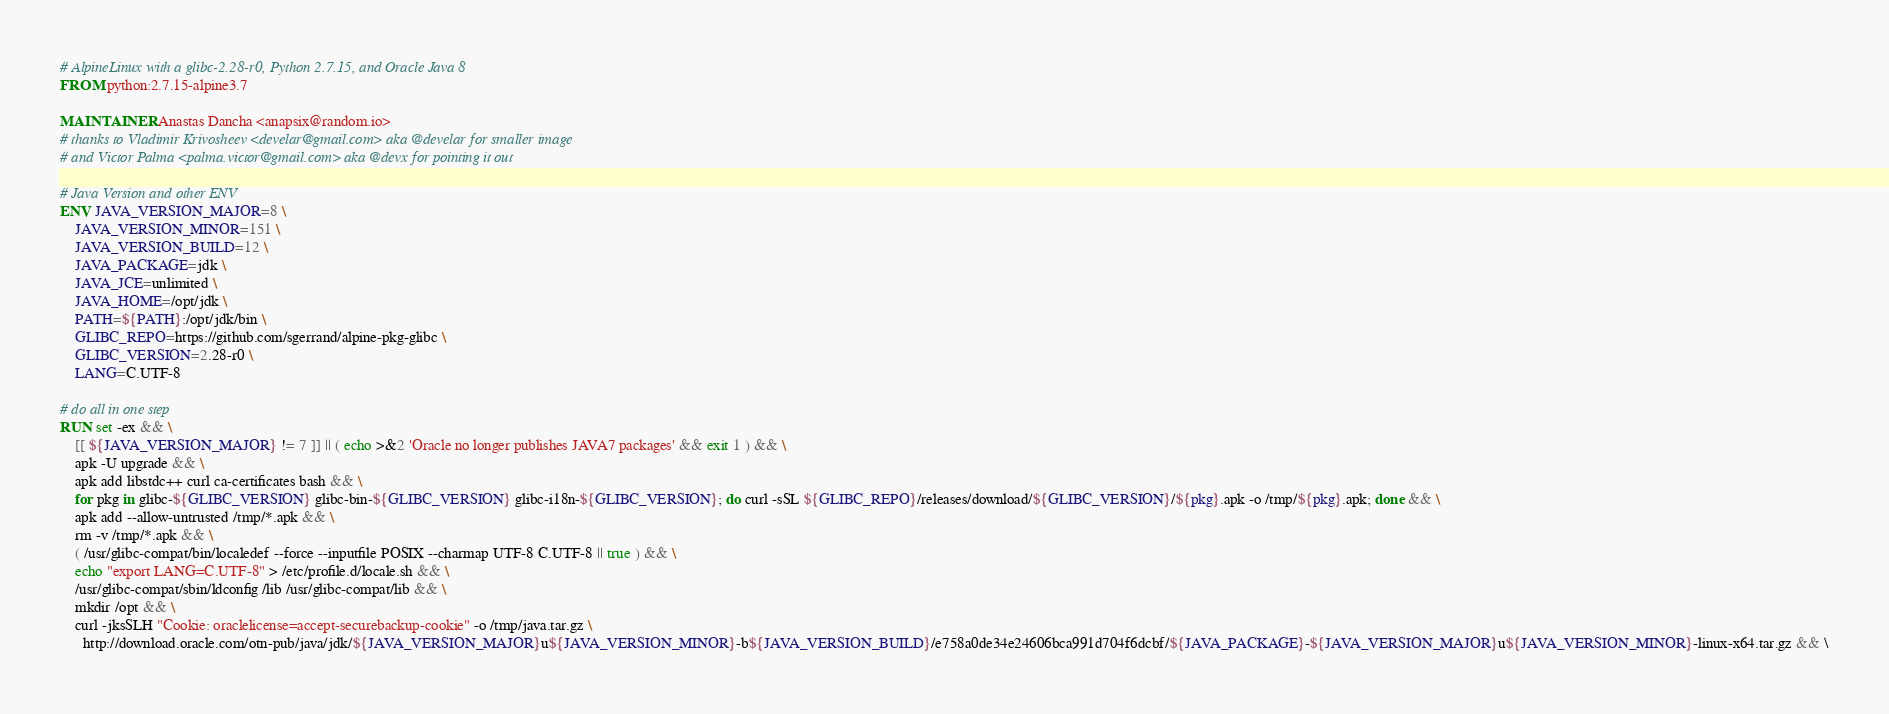<code> <loc_0><loc_0><loc_500><loc_500><_Dockerfile_># AlpineLinux with a glibc-2.28-r0, Python 2.7.15, and Oracle Java 8
FROM python:2.7.15-alpine3.7

MAINTAINER Anastas Dancha <anapsix@random.io>
# thanks to Vladimir Krivosheev <develar@gmail.com> aka @develar for smaller image
# and Victor Palma <palma.victor@gmail.com> aka @devx for pointing it out

# Java Version and other ENV
ENV JAVA_VERSION_MAJOR=8 \
    JAVA_VERSION_MINOR=151 \
    JAVA_VERSION_BUILD=12 \
    JAVA_PACKAGE=jdk \
    JAVA_JCE=unlimited \
    JAVA_HOME=/opt/jdk \
    PATH=${PATH}:/opt/jdk/bin \
    GLIBC_REPO=https://github.com/sgerrand/alpine-pkg-glibc \
    GLIBC_VERSION=2.28-r0 \
    LANG=C.UTF-8

# do all in one step
RUN set -ex && \
    [[ ${JAVA_VERSION_MAJOR} != 7 ]] || ( echo >&2 'Oracle no longer publishes JAVA7 packages' && exit 1 ) && \
    apk -U upgrade && \
    apk add libstdc++ curl ca-certificates bash && \
    for pkg in glibc-${GLIBC_VERSION} glibc-bin-${GLIBC_VERSION} glibc-i18n-${GLIBC_VERSION}; do curl -sSL ${GLIBC_REPO}/releases/download/${GLIBC_VERSION}/${pkg}.apk -o /tmp/${pkg}.apk; done && \
    apk add --allow-untrusted /tmp/*.apk && \
    rm -v /tmp/*.apk && \
    ( /usr/glibc-compat/bin/localedef --force --inputfile POSIX --charmap UTF-8 C.UTF-8 || true ) && \
    echo "export LANG=C.UTF-8" > /etc/profile.d/locale.sh && \
    /usr/glibc-compat/sbin/ldconfig /lib /usr/glibc-compat/lib && \
    mkdir /opt && \
    curl -jksSLH "Cookie: oraclelicense=accept-securebackup-cookie" -o /tmp/java.tar.gz \
      http://download.oracle.com/otn-pub/java/jdk/${JAVA_VERSION_MAJOR}u${JAVA_VERSION_MINOR}-b${JAVA_VERSION_BUILD}/e758a0de34e24606bca991d704f6dcbf/${JAVA_PACKAGE}-${JAVA_VERSION_MAJOR}u${JAVA_VERSION_MINOR}-linux-x64.tar.gz && \</code> 